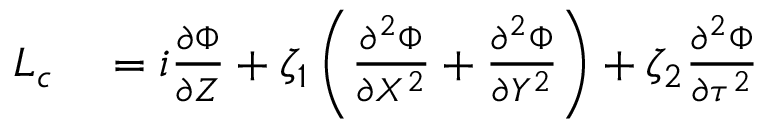<formula> <loc_0><loc_0><loc_500><loc_500>\begin{array} { r l } { { L } _ { c } } & = i \frac { \partial \Phi } { \partial Z } + \zeta _ { 1 } \left ( \frac { \partial ^ { 2 } \Phi } { \partial X ^ { 2 } } + \frac { \partial ^ { 2 } \Phi } { \partial Y ^ { 2 } } \right ) + \zeta _ { 2 } \frac { \partial ^ { 2 } \Phi } { \partial \tau ^ { 2 } } } \end{array}</formula> 